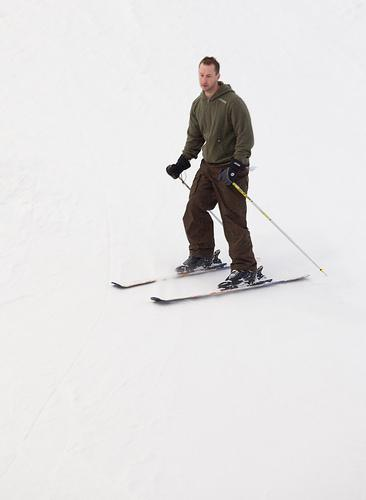Question: what color is the man's pants?
Choices:
A. Blue.
B. White.
C. Black.
D. Brown.
Answer with the letter. Answer: D Question: who is in the photo?
Choices:
A. A woman.
B. A man.
C. A boy.
D. A girl.
Answer with the letter. Answer: B Question: what is on the ground?
Choices:
A. Salt.
B. Sugar.
C. Cocaine.
D. Snow.
Answer with the letter. Answer: D 